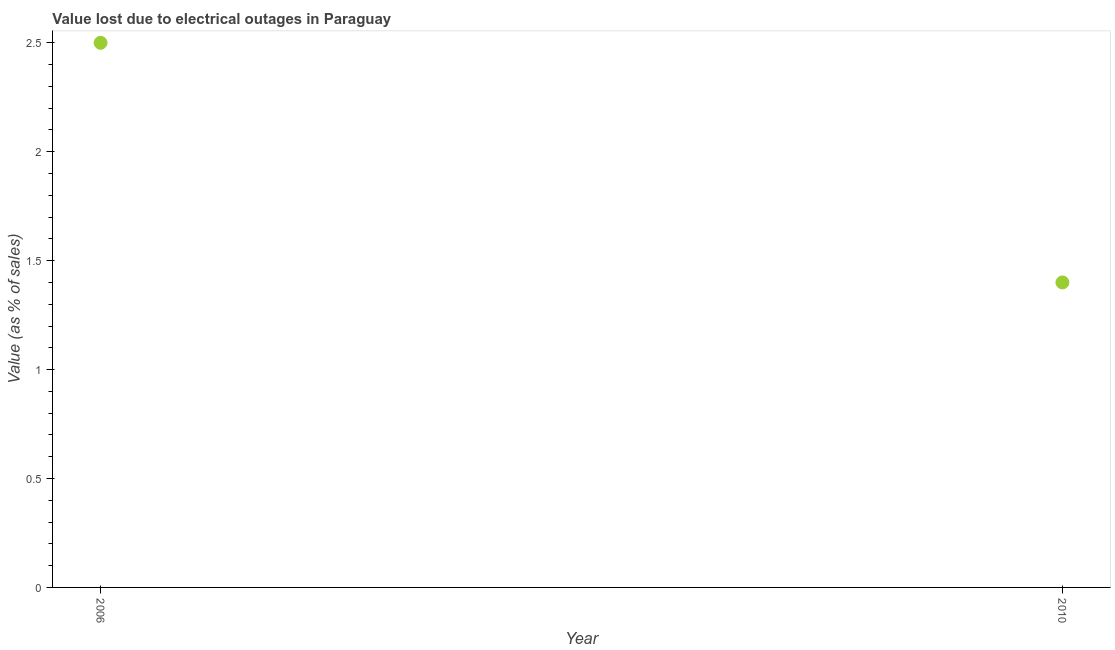Across all years, what is the maximum value lost due to electrical outages?
Give a very brief answer. 2.5. Across all years, what is the minimum value lost due to electrical outages?
Give a very brief answer. 1.4. In which year was the value lost due to electrical outages minimum?
Provide a succinct answer. 2010. What is the difference between the value lost due to electrical outages in 2006 and 2010?
Give a very brief answer. 1.1. What is the average value lost due to electrical outages per year?
Make the answer very short. 1.95. What is the median value lost due to electrical outages?
Provide a succinct answer. 1.95. In how many years, is the value lost due to electrical outages greater than 0.7 %?
Provide a short and direct response. 2. Do a majority of the years between 2006 and 2010 (inclusive) have value lost due to electrical outages greater than 2 %?
Ensure brevity in your answer.  No. What is the ratio of the value lost due to electrical outages in 2006 to that in 2010?
Give a very brief answer. 1.79. Is the value lost due to electrical outages in 2006 less than that in 2010?
Keep it short and to the point. No. In how many years, is the value lost due to electrical outages greater than the average value lost due to electrical outages taken over all years?
Your answer should be very brief. 1. How many dotlines are there?
Give a very brief answer. 1. How many years are there in the graph?
Your answer should be very brief. 2. What is the difference between two consecutive major ticks on the Y-axis?
Provide a succinct answer. 0.5. Are the values on the major ticks of Y-axis written in scientific E-notation?
Ensure brevity in your answer.  No. What is the title of the graph?
Your answer should be very brief. Value lost due to electrical outages in Paraguay. What is the label or title of the Y-axis?
Make the answer very short. Value (as % of sales). What is the difference between the Value (as % of sales) in 2006 and 2010?
Keep it short and to the point. 1.1. What is the ratio of the Value (as % of sales) in 2006 to that in 2010?
Give a very brief answer. 1.79. 